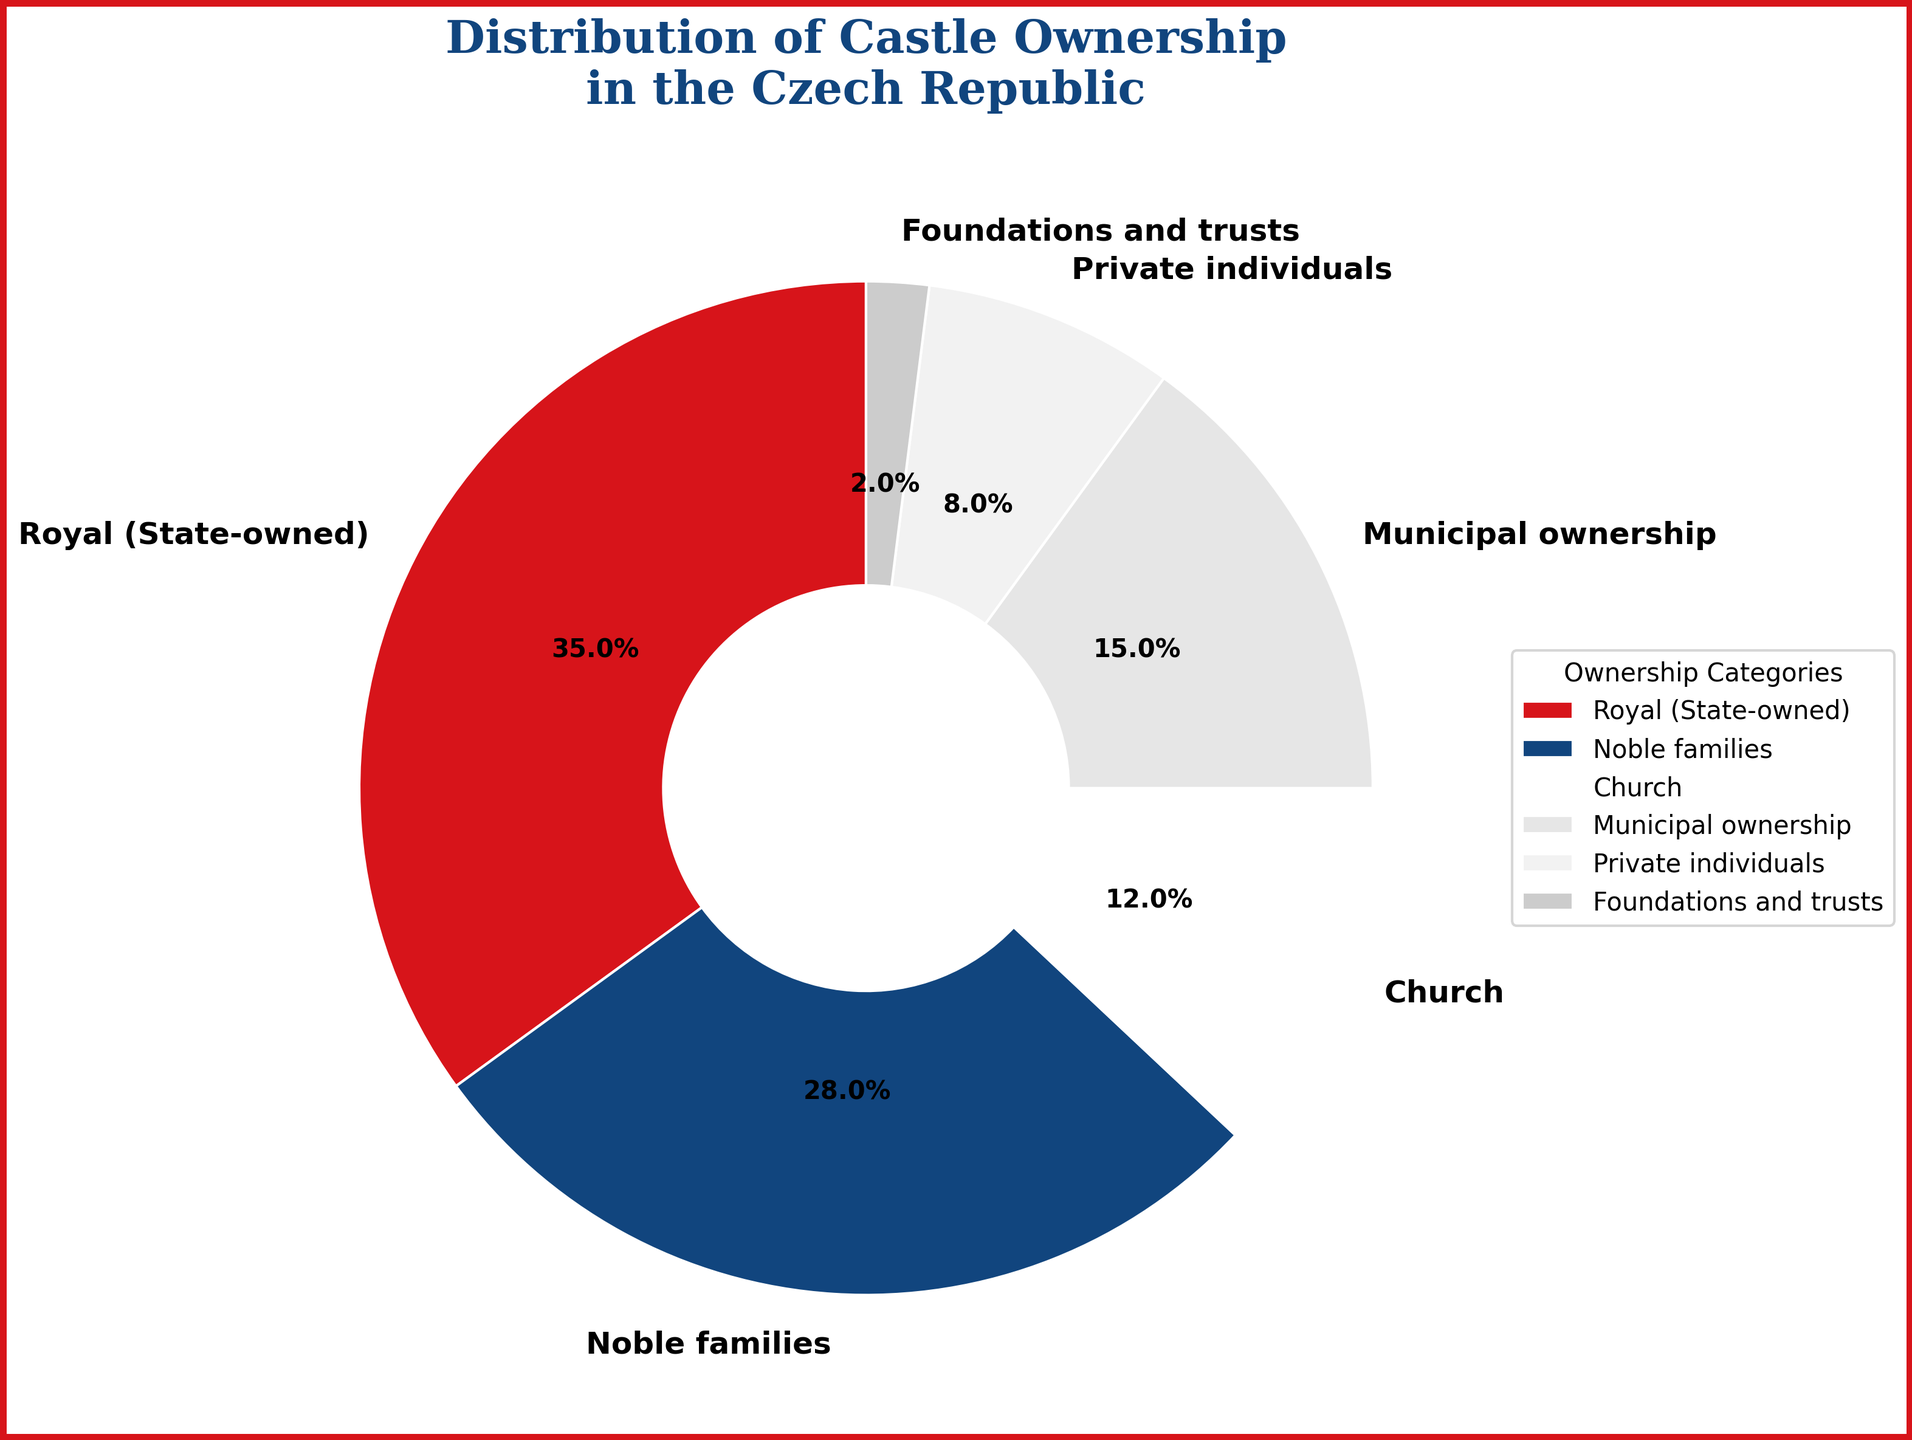What percentage of castles are owned by private individuals? Refer to the pie chart and find the segment labeled "Private individuals". The corresponding percentage is provided within the segment.
Answer: 8% Which category has the largest ownership of castles in the Czech Republic? Look at the pie chart and identify the segment with the highest percentage. The largest segment is labeled "Royal (State-owned)" with 35%.
Answer: Royal (State-owned) What's the combined percentage for castles owned by noble families and the church? Locate the segments for "Noble families" and "Church". Add their percentages: 28% (Noble families) + 12% (Church) = 40%.
Answer: 40% Are there more castles owned by municipalities or by private individuals? Compare the percentage segments of "Municipal ownership" and "Private individuals". Municipal ownership has 15%, which is larger than private individuals at 8%.
Answer: Municipal ownership What is the difference in ownership percentage between royal (state-owned) and foundations & trusts? Identify the percentages for both categories: Royal (State-owned) is 35% and Foundations and trusts is 2%. Subtract the two: 35% - 2% = 33%.
Answer: 33% Which segment is represented by the color blue? Refer to the pie chart and match the color blue to the corresponding segment. The blue color represents "Noble families".
Answer: Noble families How does the percentage of castles owned by the church compare to those owned by foundations and trusts? Compare the segments for "Church" and "Foundations and trusts". Church ownership is 12% and foundations and trusts ownership is 2%. The church owns a larger percentage.
Answer: Church Is the percentage of municipal ownership greater or less than the sum of church and private individuals' ownership? Municipal ownership is 15%. Sum the percentages for Church and Private individuals: 12% (Church) + 8% (Private individuals) = 20%. Municipal ownership (15%) is less than the combined 20%.
Answer: Less What is the total percentage of castles owned by non-state entities (excluding Royal (State-owned))? Sum the percentages of the non-state categories: Noble families 28% + Church 12% + Municipal ownership 15% + Private individuals 8% + Foundations and trusts 2%. Total = 28% + 12% + 15% + 8% + 2% = 65%.
Answer: 65% What’s the percentage difference between the two smallest ownership categories? Identify the two smallest segments: "Foundations and trusts" (2%) and "Private individuals" (8%). Calculate the difference: 8% - 2% = 6%.
Answer: 6% 